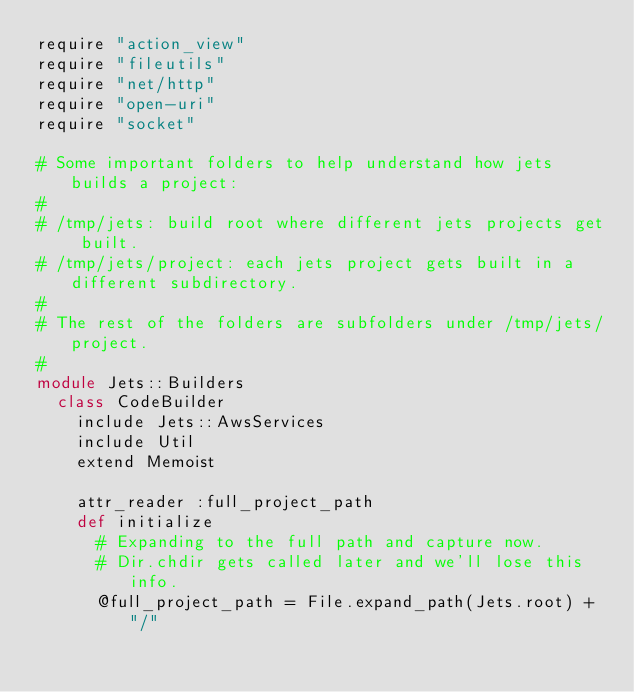Convert code to text. <code><loc_0><loc_0><loc_500><loc_500><_Ruby_>require "action_view"
require "fileutils"
require "net/http"
require "open-uri"
require "socket"

# Some important folders to help understand how jets builds a project:
#
# /tmp/jets: build root where different jets projects get built.
# /tmp/jets/project: each jets project gets built in a different subdirectory.
#
# The rest of the folders are subfolders under /tmp/jets/project.
#
module Jets::Builders
  class CodeBuilder
    include Jets::AwsServices
    include Util
    extend Memoist

    attr_reader :full_project_path
    def initialize
      # Expanding to the full path and capture now.
      # Dir.chdir gets called later and we'll lose this info.
      @full_project_path = File.expand_path(Jets.root) + "/"</code> 